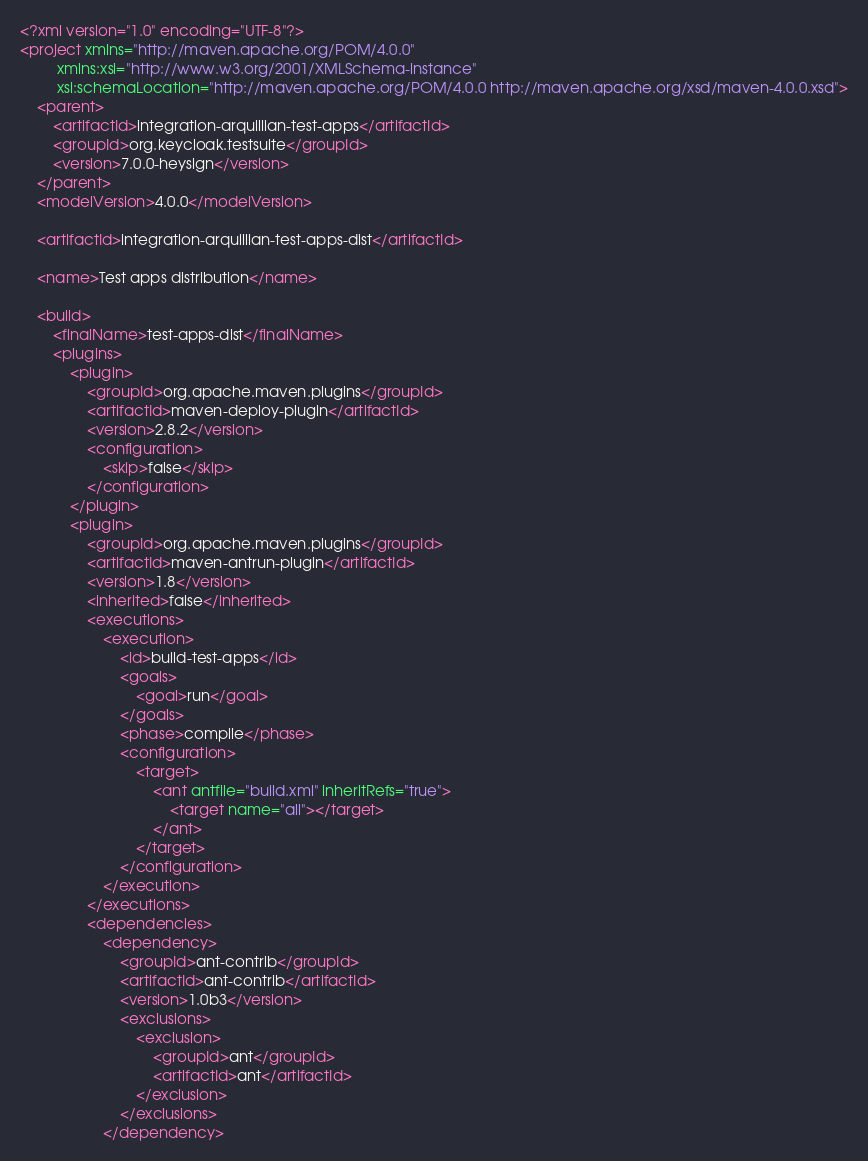<code> <loc_0><loc_0><loc_500><loc_500><_XML_><?xml version="1.0" encoding="UTF-8"?>
<project xmlns="http://maven.apache.org/POM/4.0.0"
         xmlns:xsi="http://www.w3.org/2001/XMLSchema-instance"
         xsi:schemaLocation="http://maven.apache.org/POM/4.0.0 http://maven.apache.org/xsd/maven-4.0.0.xsd">
    <parent>
        <artifactId>integration-arquillian-test-apps</artifactId>
        <groupId>org.keycloak.testsuite</groupId>
        <version>7.0.0-heysign</version>
    </parent>
    <modelVersion>4.0.0</modelVersion>

    <artifactId>integration-arquillian-test-apps-dist</artifactId>

    <name>Test apps distribution</name>

    <build>
        <finalName>test-apps-dist</finalName>
        <plugins>
            <plugin>
                <groupId>org.apache.maven.plugins</groupId>
                <artifactId>maven-deploy-plugin</artifactId>
                <version>2.8.2</version>
                <configuration>
                    <skip>false</skip>
                </configuration>
            </plugin>
            <plugin>
                <groupId>org.apache.maven.plugins</groupId>
                <artifactId>maven-antrun-plugin</artifactId>
                <version>1.8</version>
                <inherited>false</inherited>
                <executions>
                    <execution>
                        <id>build-test-apps</id>
                        <goals>
                            <goal>run</goal>
                        </goals>
                        <phase>compile</phase>
                        <configuration>
                            <target>
                                <ant antfile="build.xml" inheritRefs="true">
                                    <target name="all"></target>
                                </ant>
                            </target>
                        </configuration>
                    </execution>
                </executions>
                <dependencies>
                    <dependency>
                        <groupId>ant-contrib</groupId>
                        <artifactId>ant-contrib</artifactId>
                        <version>1.0b3</version>
                        <exclusions>
                            <exclusion>
                                <groupId>ant</groupId>
                                <artifactId>ant</artifactId>
                            </exclusion>
                        </exclusions>
                    </dependency></code> 